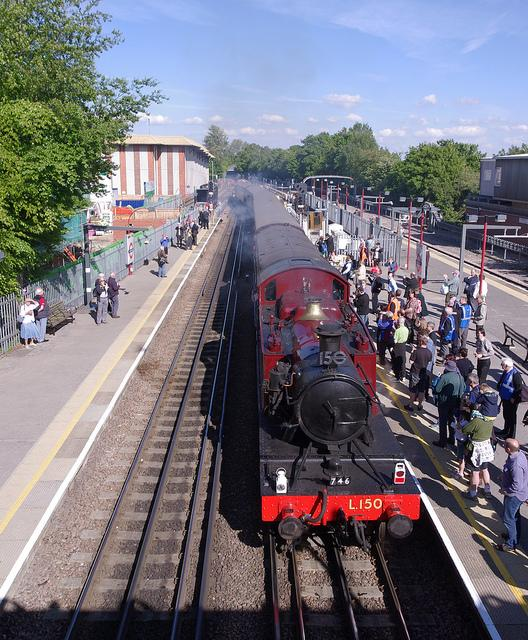What is the gold object near the front of the train? Please explain your reasoning. bell. Its a bell that rings to let people know that its coming down the tracks. 